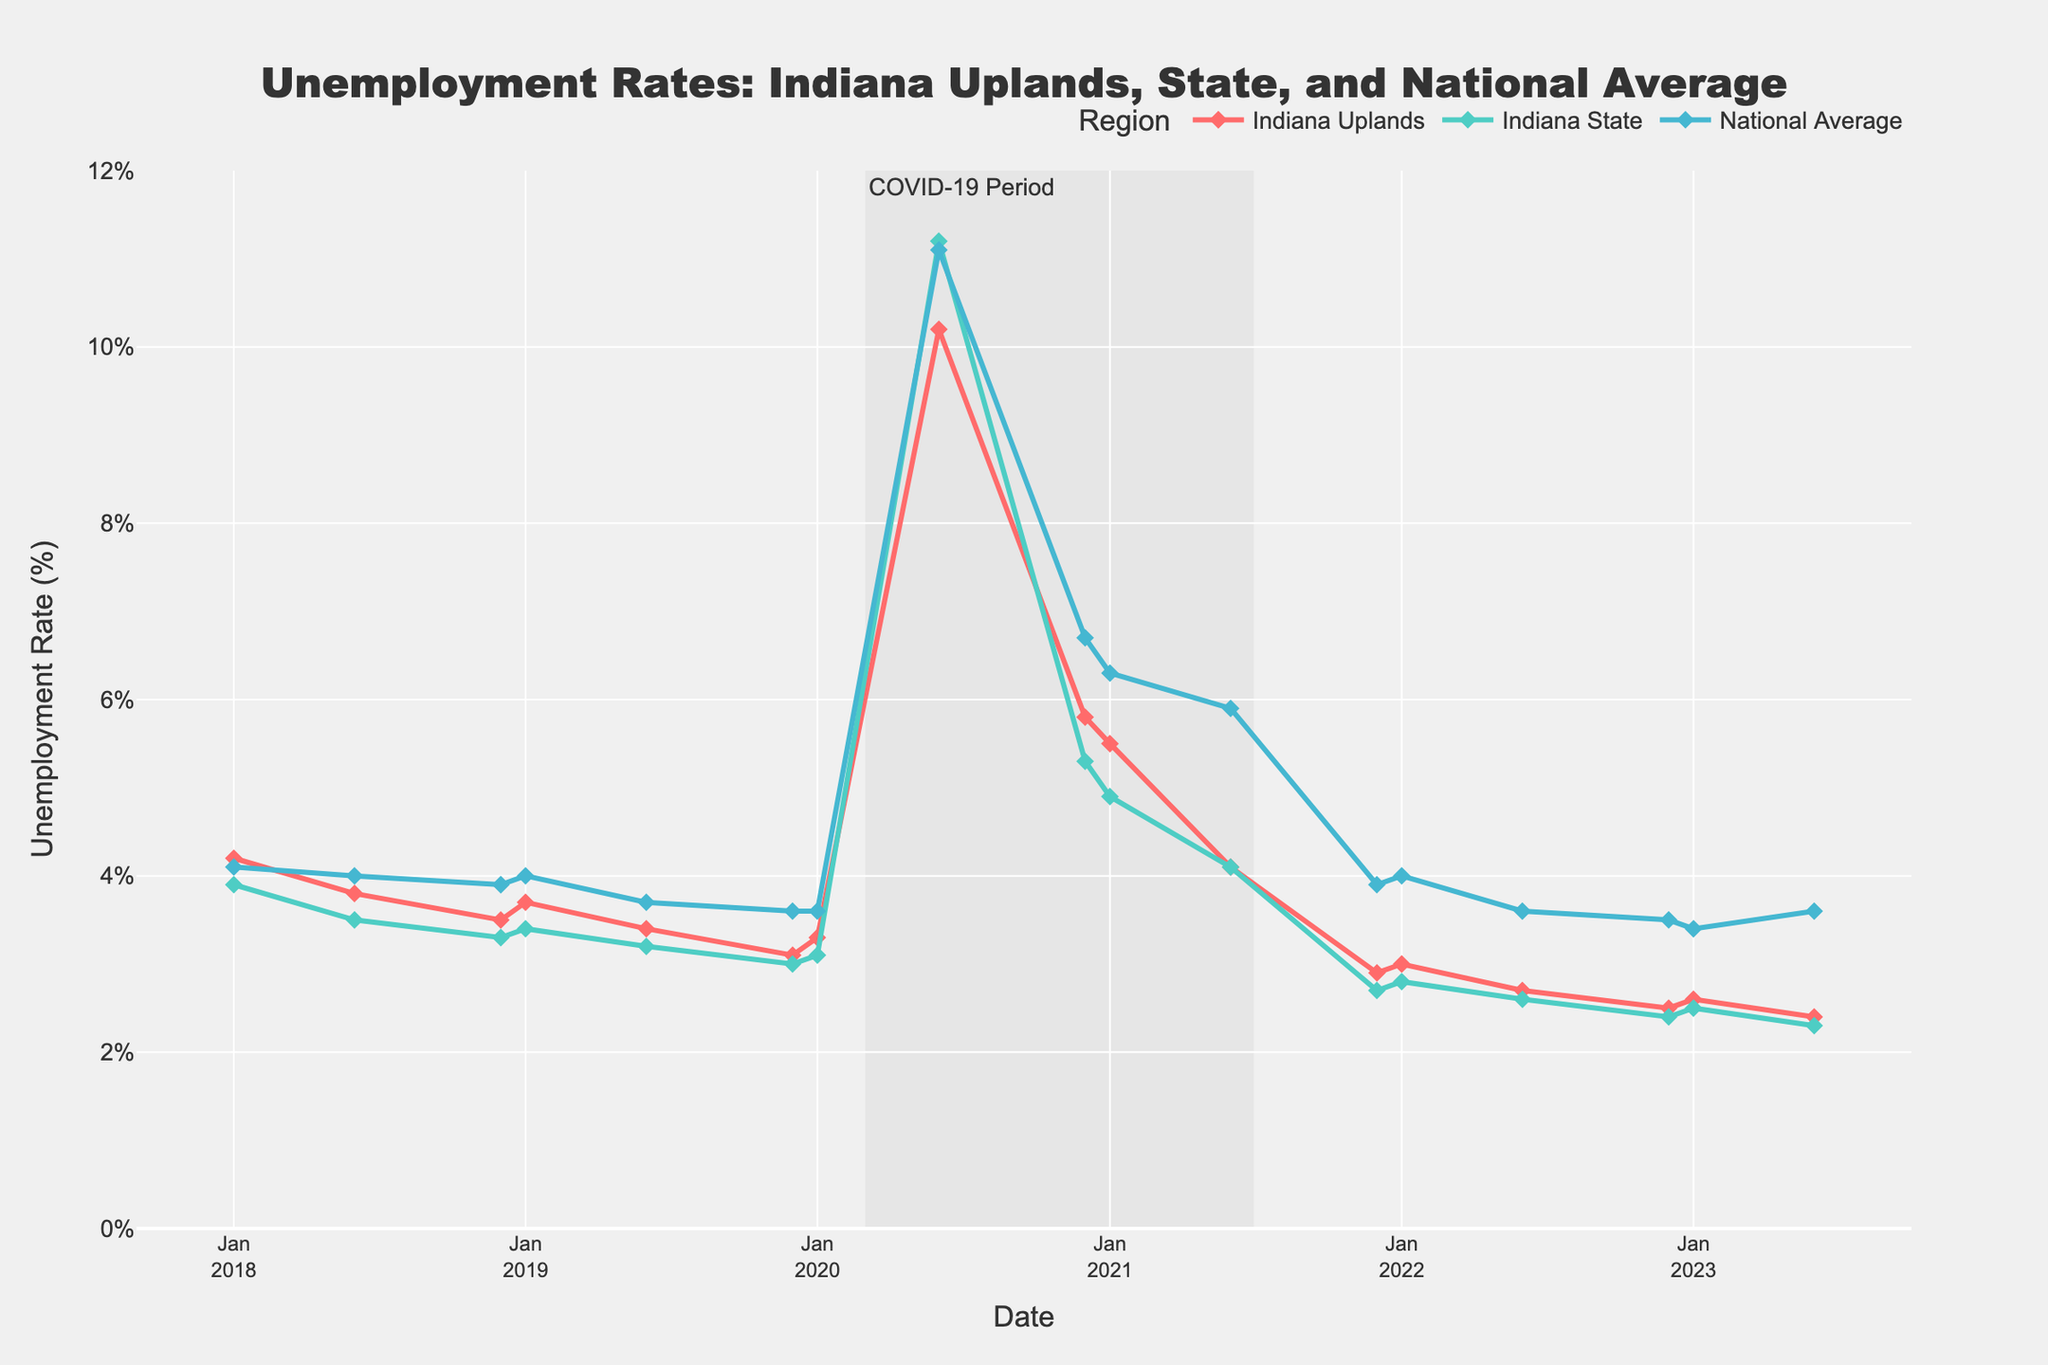What was the unemployment rate in Indiana Uplands at the beginning of 2020? Locate the data point for January 2020 on the x-axis and find its corresponding y-value for Indiana Uplands (red line).
Answer: 3.3% During which period did the unemployment rate for Indiana State exceed that of the National Average? Observe the two relevant lines on the plot (green for Indiana State and blue for National Average) and identify any periods where the green line is above the blue line. Specifically, this occurs between June 2020 and December 2020.
Answer: June 2020 - December 2020 In June 2020, how did the unemployment rate of Indiana Uplands compare to the National Average? Look at the data points for June 2020 on the plot and compare the y-values for Indiana Uplands (red line) and National Average (blue line).
Answer: Indiana Uplands had a lower rate What is the overall trend in unemployment rates for Indiana Uplands from 2018 to 2023? Trace the red line from left to right on the plot, observing whether it generally rises, falls, or remains constant over the period.
Answer: Generally decreasing During the COVID-19 period, which region experienced the highest peak unemployment rate? Identify the peak points within the shaded area (March 2020 - June 2021) and compare the maximum y-values of the three lines.
Answer: Indiana State What was the difference in unemployment rates between Indiana State and Indiana Uplands in December 2021? Locate the data points for December 2021 and subtract the y-value for Indiana Uplands (red line) from Indiana State (green line).
Answer: 0.2% Between January 2022 and June 2022, how did the unemployment rate change for the National Average? Find the data points for these two dates on the x-axis for the National Average (blue line) and compare their y-values, noting the direction and magnitude of the change.
Answer: Decreased by 0.4% Which region showed the highest unemployment rate resilience during the COVID-19 peak in 2020? Identify the region with the smallest peak value within the shaded area and compare the height of the peaks for each line.
Answer: Indiana Uplands By how much did the unemployment rate in Indiana Uplands decrease from June 2020 to December 2020? Find the y-values for Indiana Uplands at the two dates, then subtract the December 2020 value from the June 2020 value.
Answer: 4.4% Is the unemployment rate for Indiana Uplands always below the National Average? Examine the red and blue lines throughout the entire chart to determine if the red line is consistently below the blue line.
Answer: No 